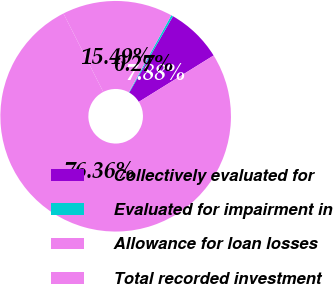Convert chart to OTSL. <chart><loc_0><loc_0><loc_500><loc_500><pie_chart><fcel>Collectively evaluated for<fcel>Evaluated for impairment in<fcel>Allowance for loan losses<fcel>Total recorded investment<nl><fcel>7.88%<fcel>0.27%<fcel>15.49%<fcel>76.36%<nl></chart> 